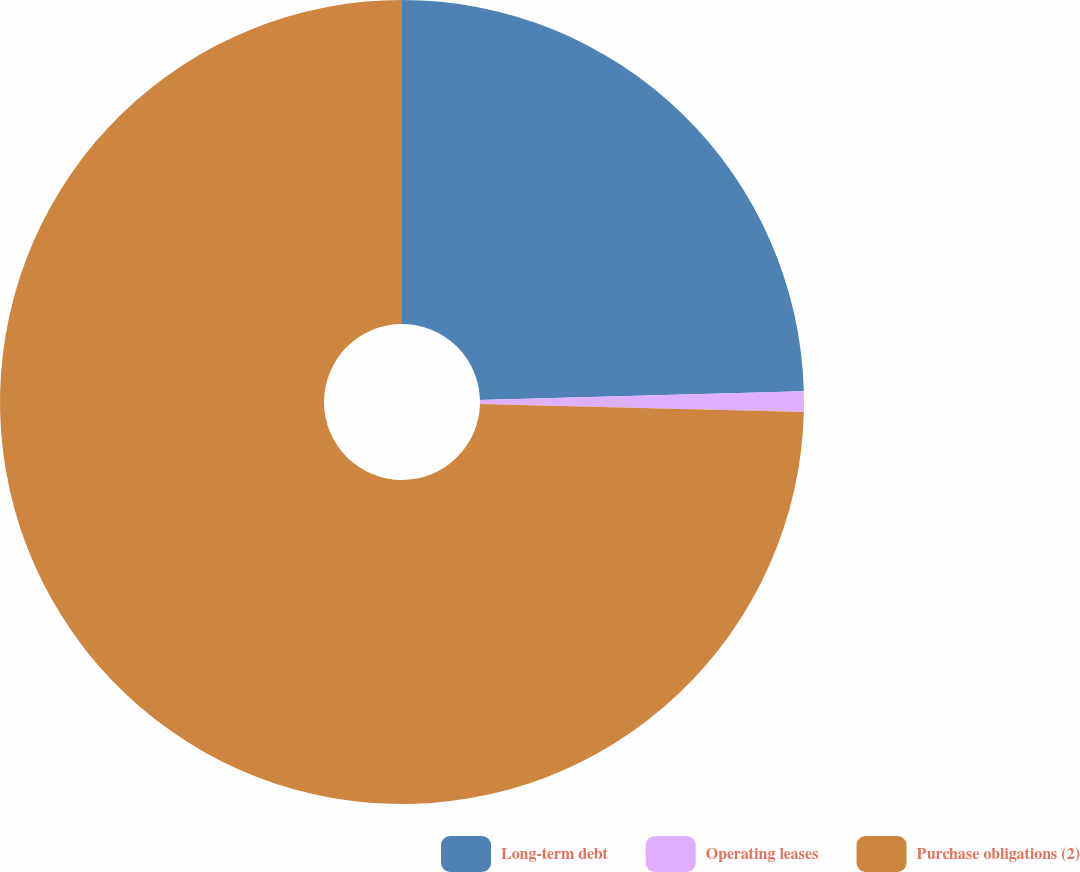Convert chart to OTSL. <chart><loc_0><loc_0><loc_500><loc_500><pie_chart><fcel>Long-term debt<fcel>Operating leases<fcel>Purchase obligations (2)<nl><fcel>24.57%<fcel>0.83%<fcel>74.6%<nl></chart> 